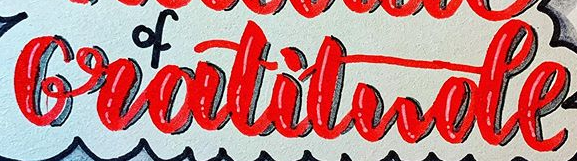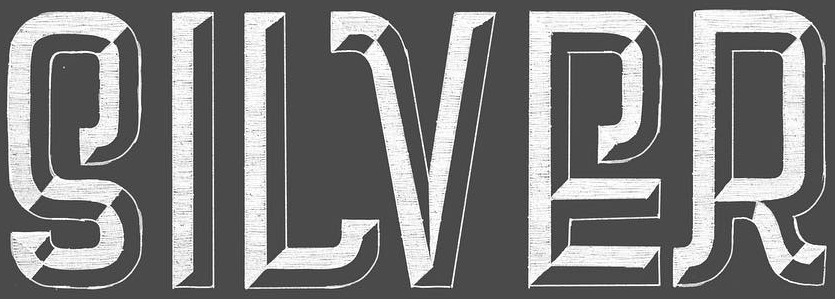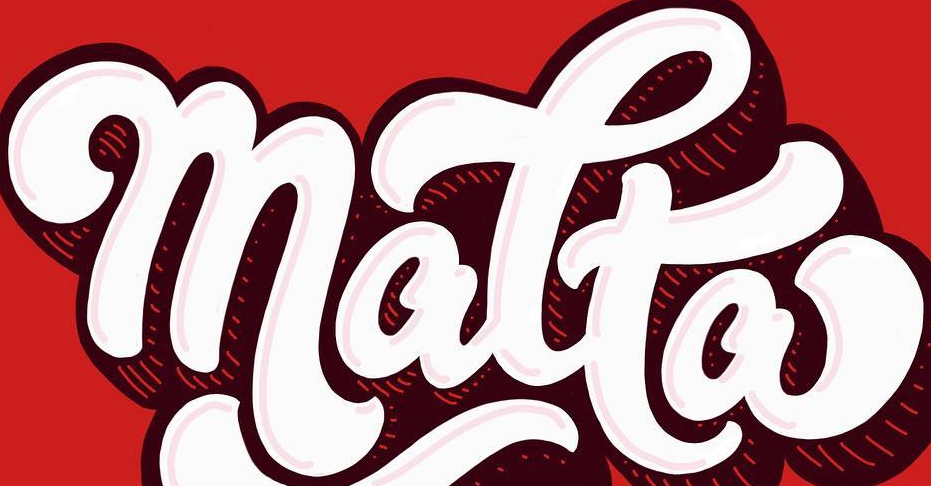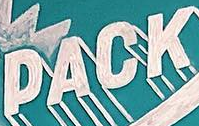What words can you see in these images in sequence, separated by a semicolon? Gratitude; SILVER; matta; PACK 